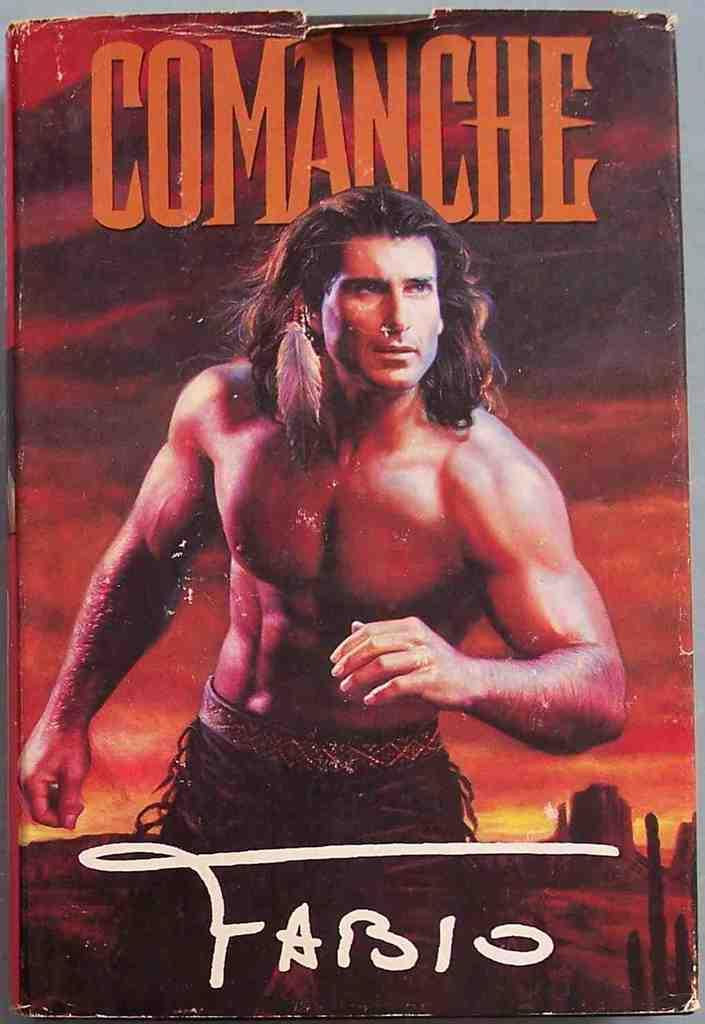What is featured on the poster in the image? The poster contains an image of a man and images of buildings. What else can be seen on the poster besides the images? The sky is visible on the poster, and clouds are present in the sky. Is there any text on the poster? Yes, there is text written on the poster. What type of clam is being cooked in the oven on the poster? There is no clam or oven present on the poster; it features an image of a man, buildings, and text. 